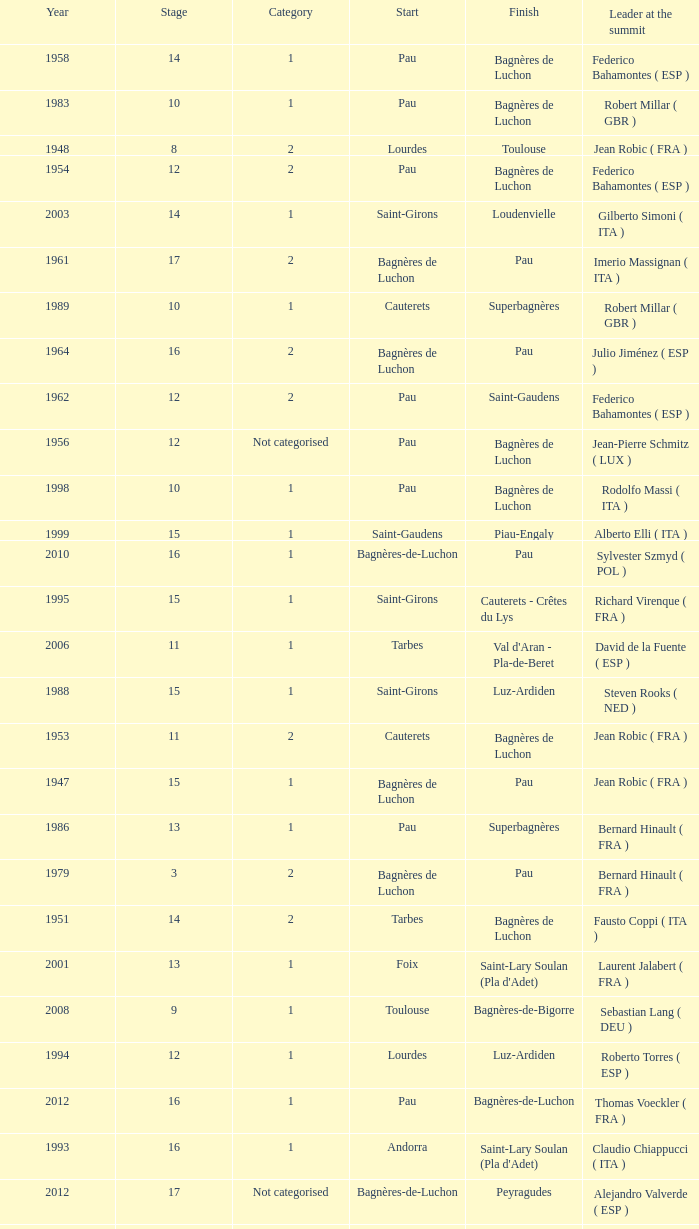What stage has a start of saint-girons in 1988? 15.0. 